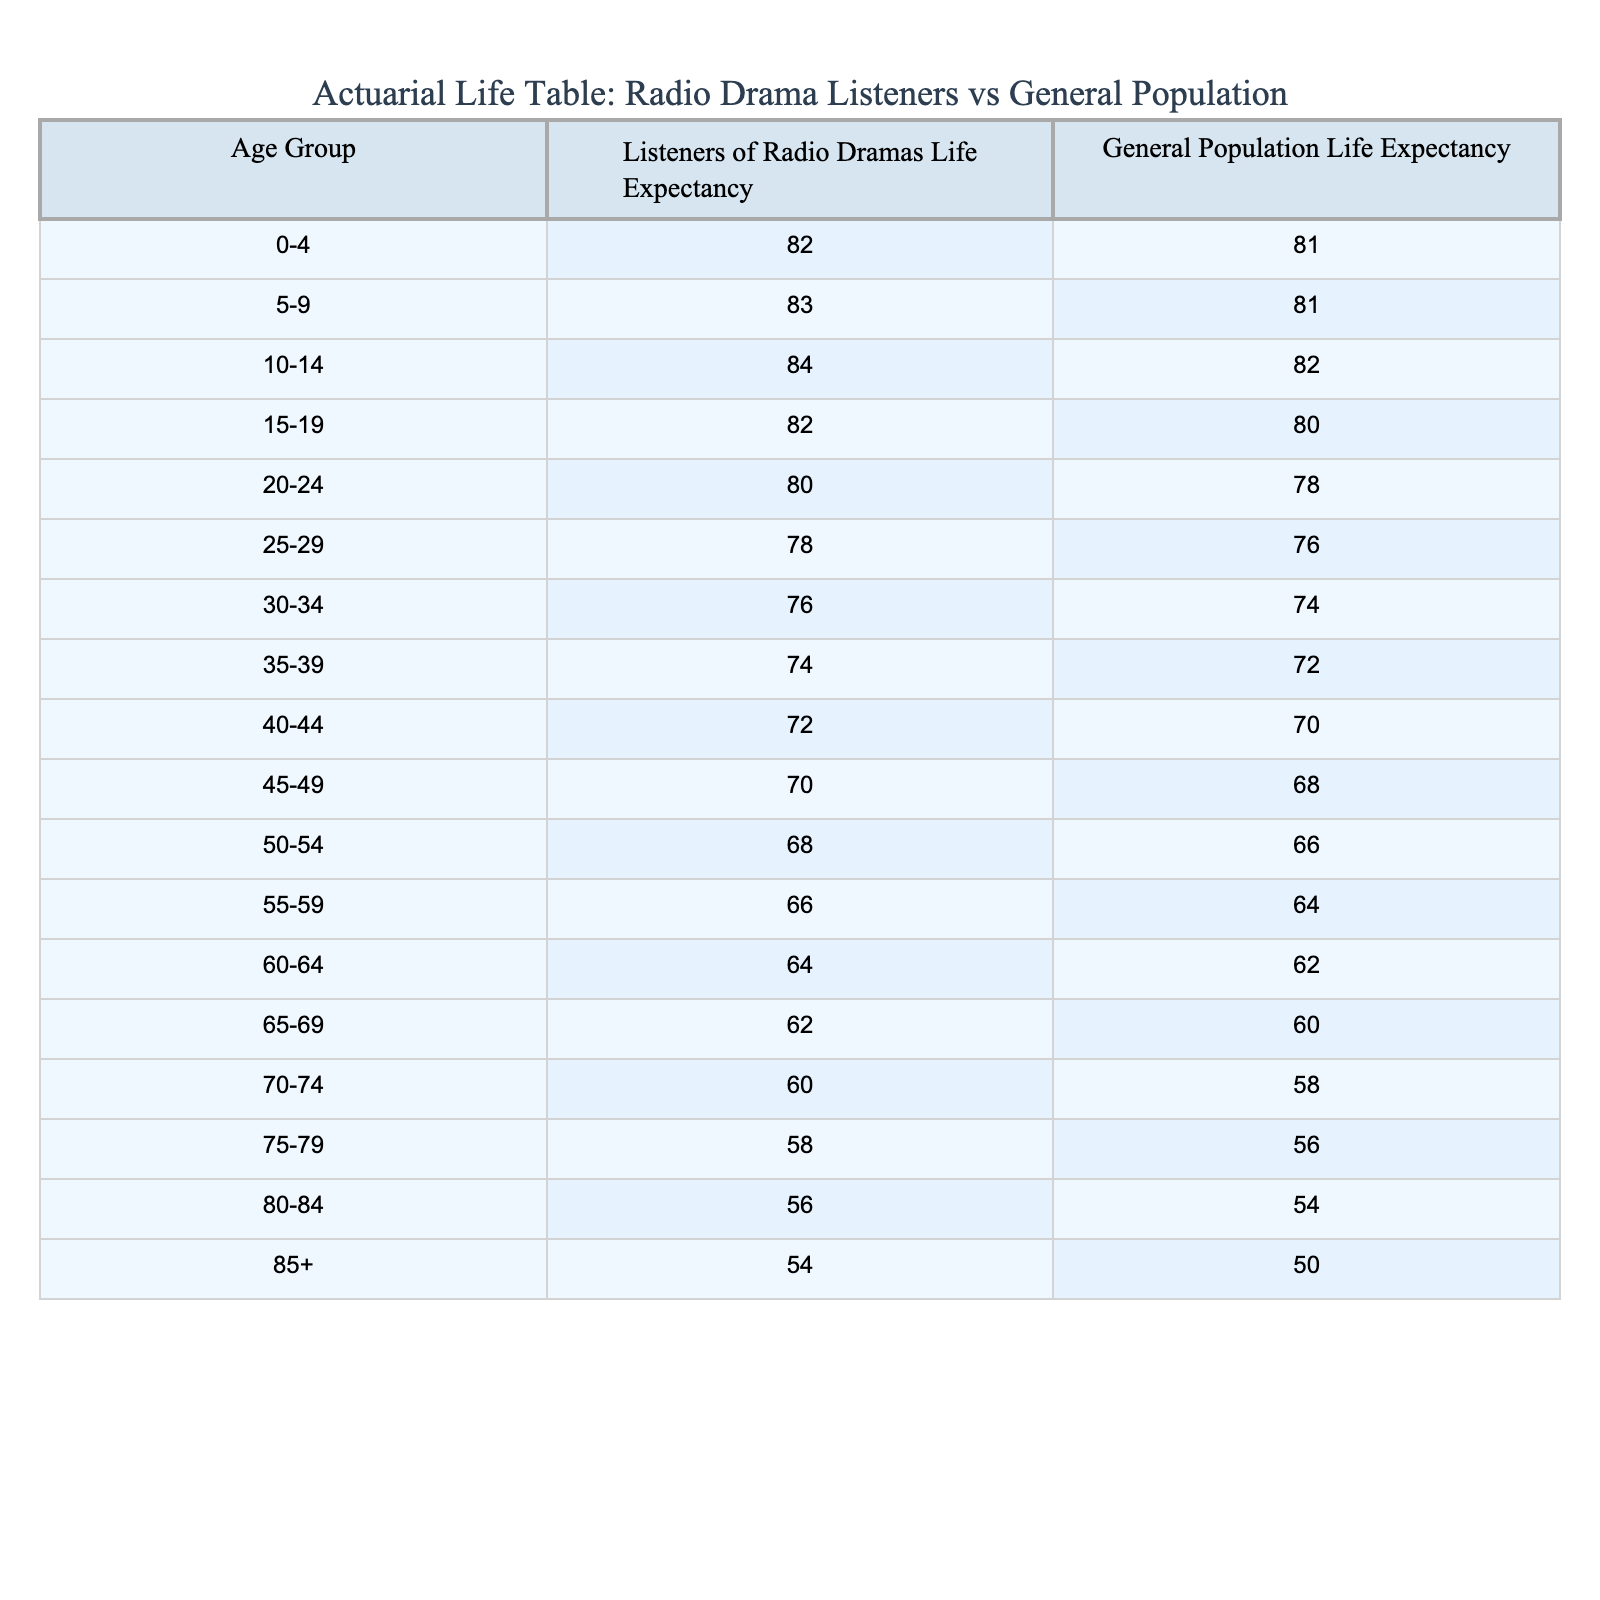What is the life expectancy of 15-19 year old listeners of radio dramas? According to the table, the life expectancy of 15-19 year old listeners of radio dramas is 82 years.
Answer: 82 What is the life expectancy of the general population for the age group 70-74? The life expectancy for the general population in the 70-74 age group is 58 years.
Answer: 58 How much higher is the life expectancy of listeners of radio dramas in the 40-44 age group compared to the general population? For the 40-44 age group, the life expectancy of listeners is 72 years and that of the general population is 70 years. The difference is 72 - 70 = 2 years.
Answer: 2 years What is the average life expectancy for listeners of radio dramas across all age groups? To find the average, we sum the life expectancies for all age groups (82 + 83 + 84 + ... + 54) which totals to 1123, and divide by the number of age groups (18). This gives an average life expectancy of 62.39 years (rounded to two decimal places).
Answer: 62.39 Is the life expectancy of listeners of radio dramas higher than that of the general population for all age groups? By reviewing the table, it's evident that listeners of radio dramas have a higher life expectancy than the general population in every age group listed.
Answer: Yes What is the life expectancy for listeners of radio dramas at age 85 and above? The life expectancy for listeners of radio dramas in the 85+ age group is 54 years.
Answer: 54 How does the life expectancy of 25-29 year old listeners of radio dramas compare to that of general population in the same age group? For the 25-29 group, the life expectancy for listeners of radio dramas is 78 years, while for the general population, it is 76 years. This means that listeners of radio dramas live 2 years longer on average in this age group.
Answer: 2 years longer Are there any age groups where the life expectancy of listeners is lower than that of the general population? Checking the life expectancies in the table, we see that listeners of radio dramas consistently have equal or higher life expectancies than the general population across all age groups.
Answer: No 